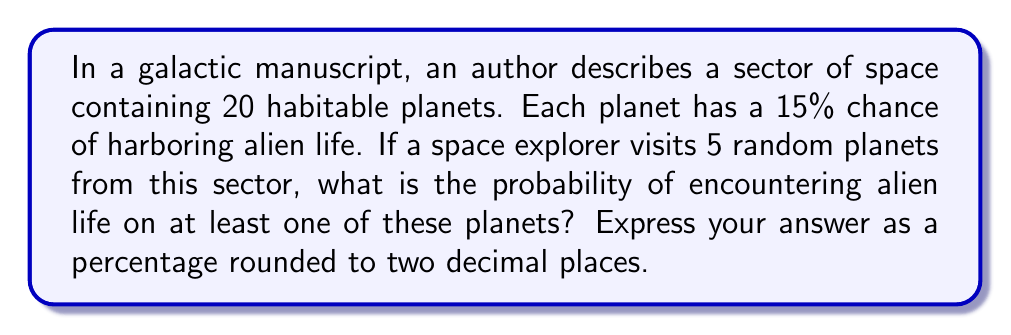Provide a solution to this math problem. Let's approach this step-by-step using combinatorics:

1) First, let's calculate the probability of not encountering alien life on a single planet:
   $P(\text{no alien life}) = 1 - 0.15 = 0.85$

2) Now, for the space explorer to not encounter alien life on any of the 5 planets, this needs to happen 5 times in a row. We can calculate this probability:
   $P(\text{no alien life on all 5}) = 0.85^5$

3) Let's calculate this:
   $0.85^5 \approx 0.4437$

4) This is the probability of not encountering alien life on any planet. We want the opposite - encountering alien life on at least one planet. We can find this by subtracting from 1:

   $P(\text{alien life on at least one}) = 1 - P(\text{no alien life on all 5})$
   $= 1 - 0.4437 = 0.5563$

5) Convert to a percentage:
   $0.5563 \times 100\% = 55.63\%$

6) Rounding to two decimal places:
   $55.63\%$

This problem uses the complement rule of probability and the multiplication rule for independent events, key concepts in combinatorics.
Answer: 55.63% 